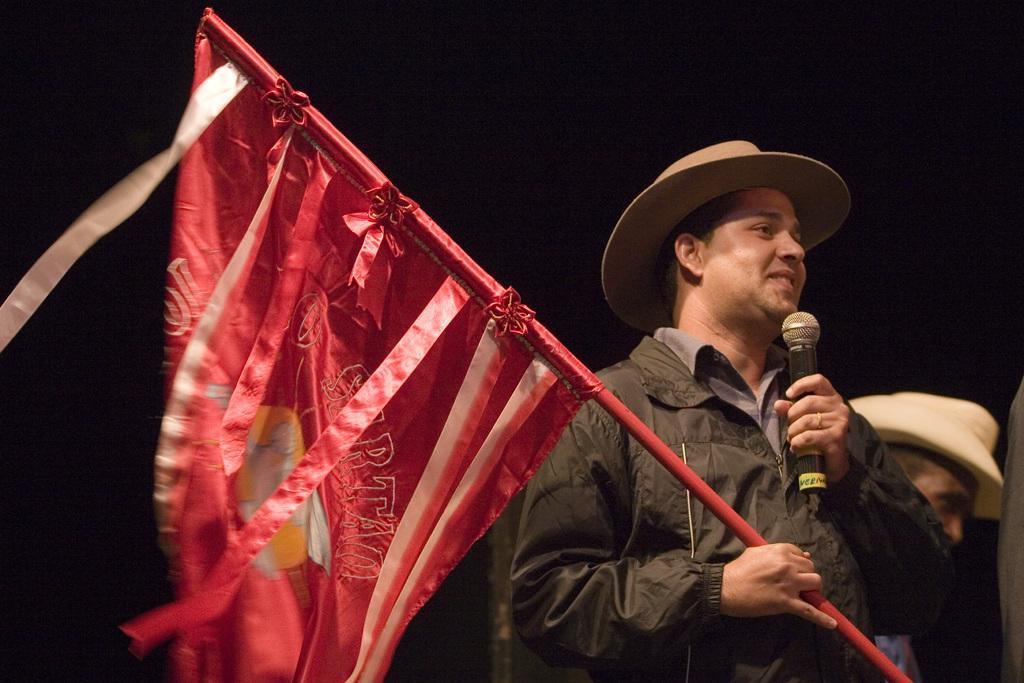In one or two sentences, can you explain what this image depicts? In this image we can see two persons, both are wearing hats, one of them is holding a flag, and a mic, also the background is dark. 